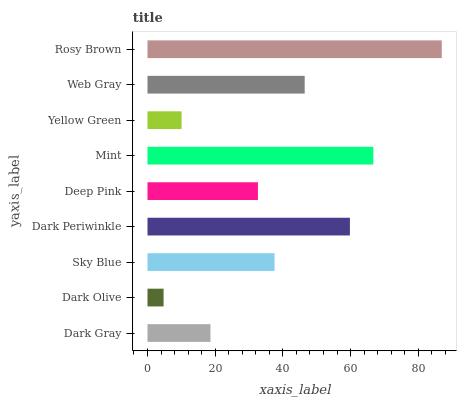Is Dark Olive the minimum?
Answer yes or no. Yes. Is Rosy Brown the maximum?
Answer yes or no. Yes. Is Sky Blue the minimum?
Answer yes or no. No. Is Sky Blue the maximum?
Answer yes or no. No. Is Sky Blue greater than Dark Olive?
Answer yes or no. Yes. Is Dark Olive less than Sky Blue?
Answer yes or no. Yes. Is Dark Olive greater than Sky Blue?
Answer yes or no. No. Is Sky Blue less than Dark Olive?
Answer yes or no. No. Is Sky Blue the high median?
Answer yes or no. Yes. Is Sky Blue the low median?
Answer yes or no. Yes. Is Rosy Brown the high median?
Answer yes or no. No. Is Dark Periwinkle the low median?
Answer yes or no. No. 